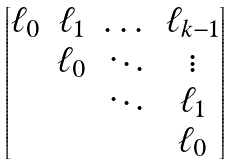<formula> <loc_0><loc_0><loc_500><loc_500>\begin{bmatrix} \ell _ { 0 } & \ell _ { 1 } & \dots & \ell _ { k - 1 } \\ & \ell _ { 0 } & \ddots & \vdots \\ & & \ddots & \ell _ { 1 } \\ & & & \ell _ { 0 } \end{bmatrix}</formula> 